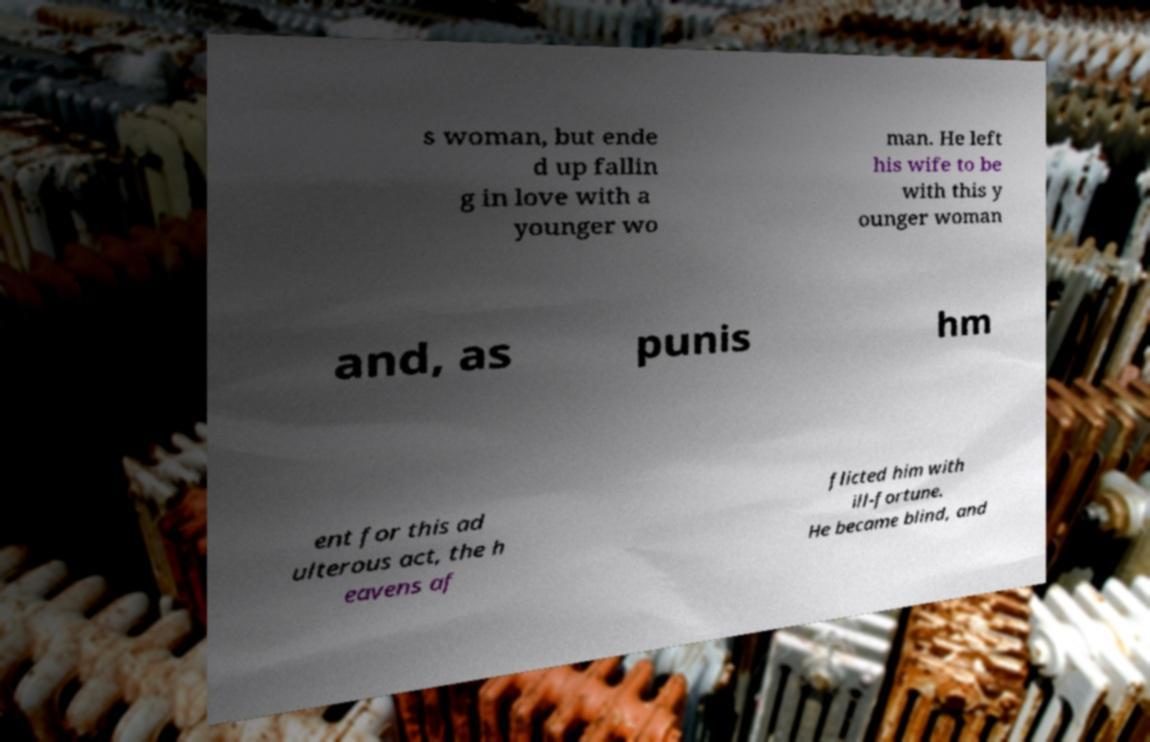For documentation purposes, I need the text within this image transcribed. Could you provide that? s woman, but ende d up fallin g in love with a younger wo man. He left his wife to be with this y ounger woman and, as punis hm ent for this ad ulterous act, the h eavens af flicted him with ill-fortune. He became blind, and 